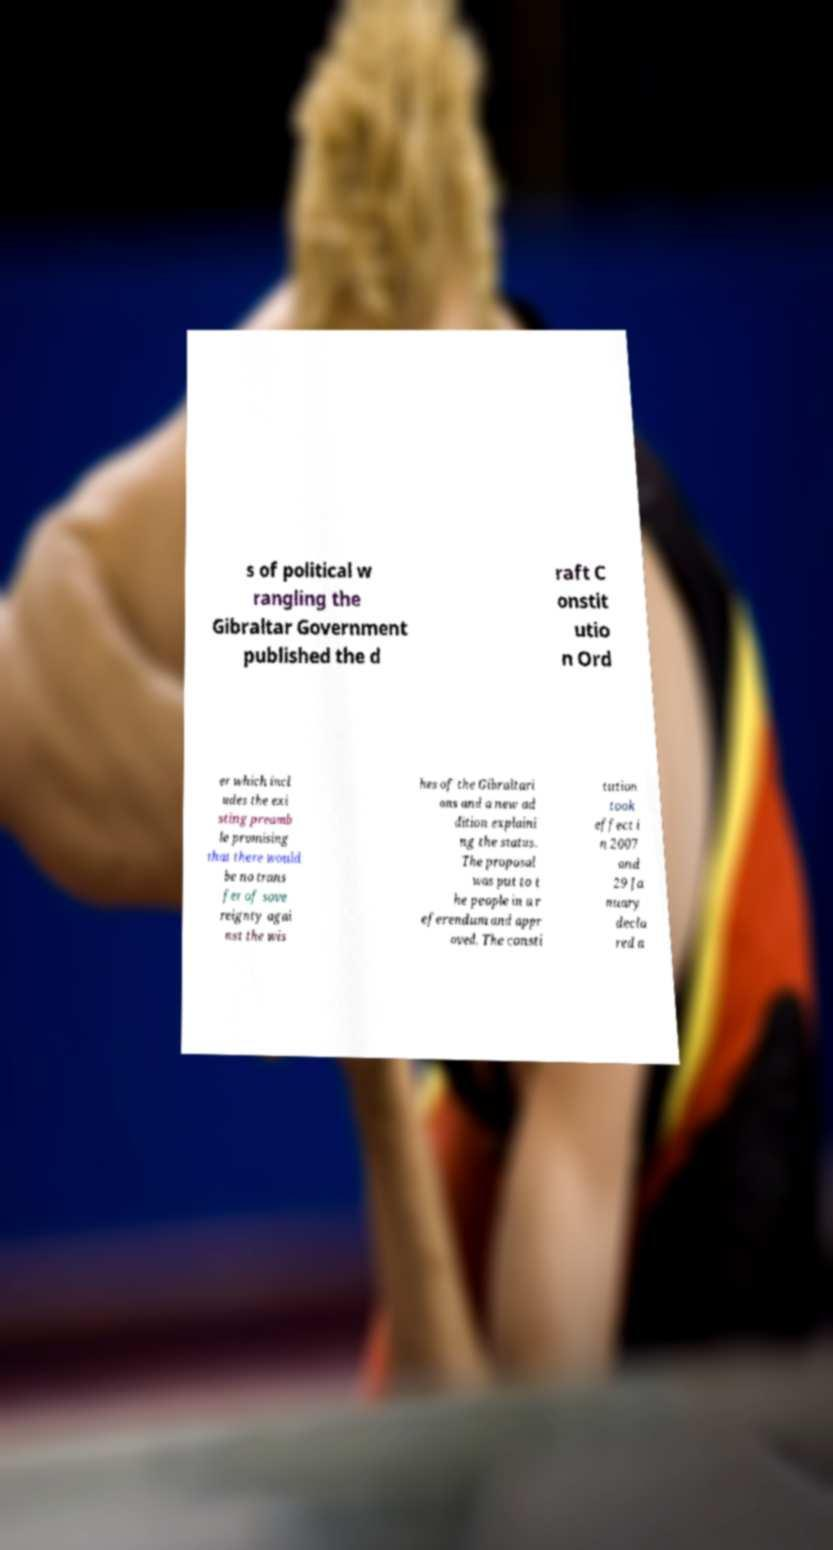Can you accurately transcribe the text from the provided image for me? s of political w rangling the Gibraltar Government published the d raft C onstit utio n Ord er which incl udes the exi sting preamb le promising that there would be no trans fer of sove reignty agai nst the wis hes of the Gibraltari ans and a new ad dition explaini ng the status. The proposal was put to t he people in a r eferendum and appr oved. The consti tution took effect i n 2007 and 29 Ja nuary decla red a 